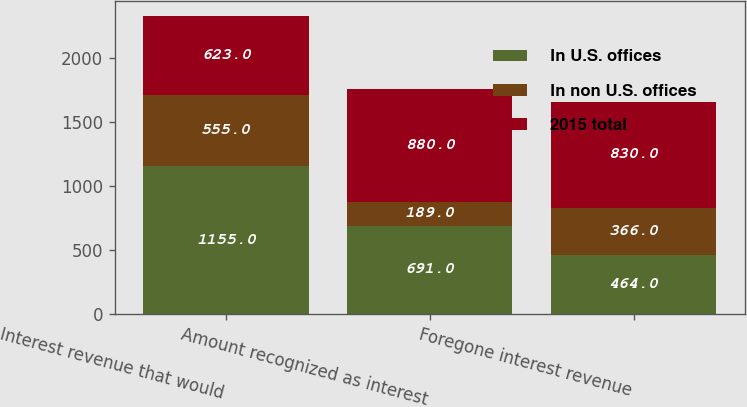<chart> <loc_0><loc_0><loc_500><loc_500><stacked_bar_chart><ecel><fcel>Interest revenue that would<fcel>Amount recognized as interest<fcel>Foregone interest revenue<nl><fcel>In U.S. offices<fcel>1155<fcel>691<fcel>464<nl><fcel>In non U.S. offices<fcel>555<fcel>189<fcel>366<nl><fcel>2015 total<fcel>623<fcel>880<fcel>830<nl></chart> 